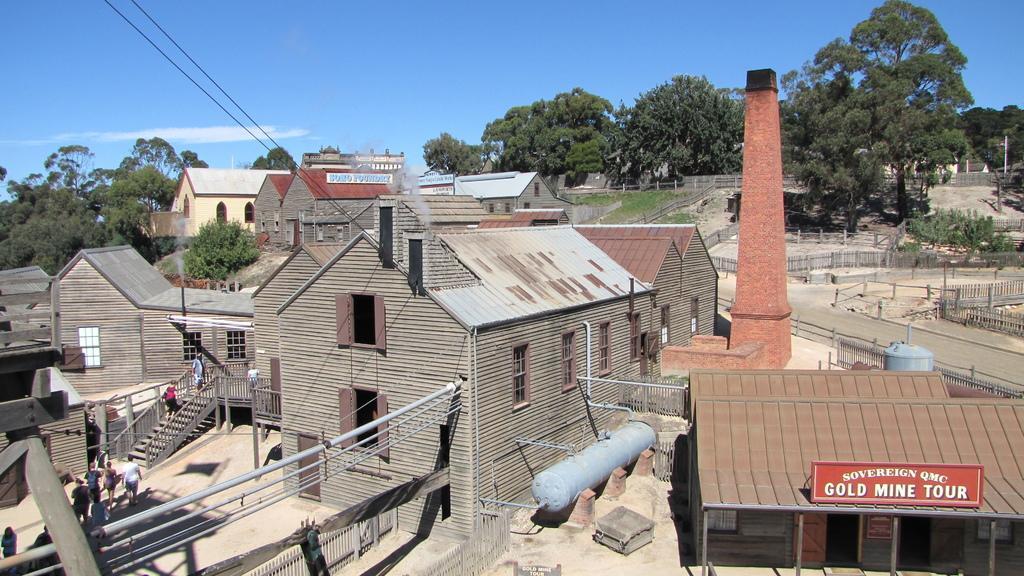Could you give a brief overview of what you see in this image? In this image we can see many buildings and houses. There is a blue and a slightly cloudy sky in the image. There are many trees in the image. There are few electrical poles in the image and some cables are connected to it. There is a road in the image. There are few people in the image. 